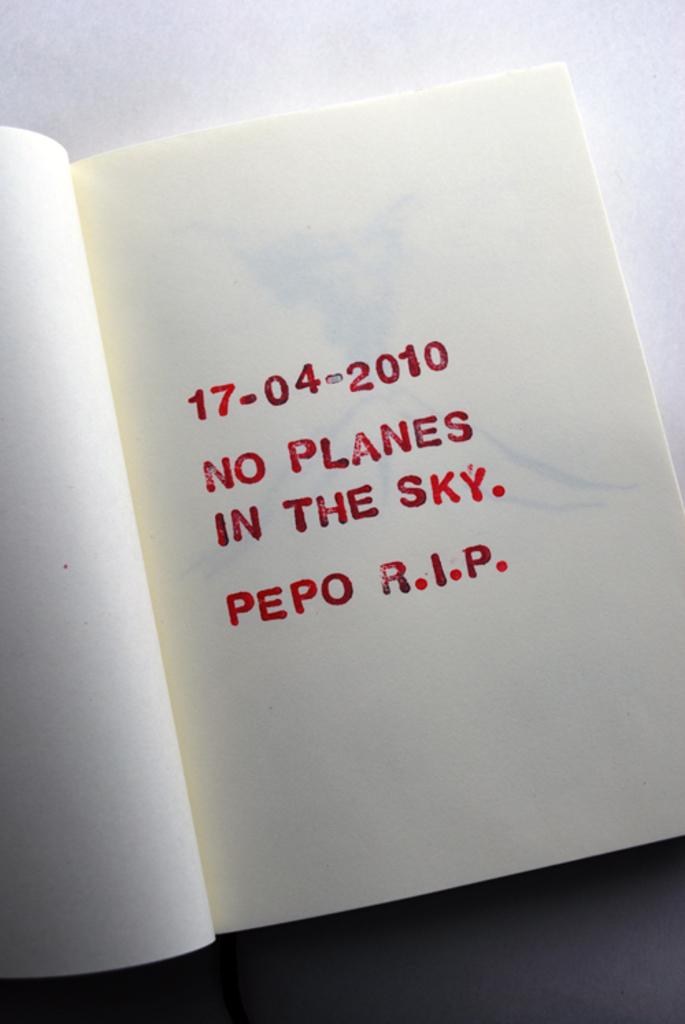What is the date presented in the book?
Your response must be concise. 17-04-2010. What happened on 17-4-2010?
Provide a short and direct response. No planes in the sky. 